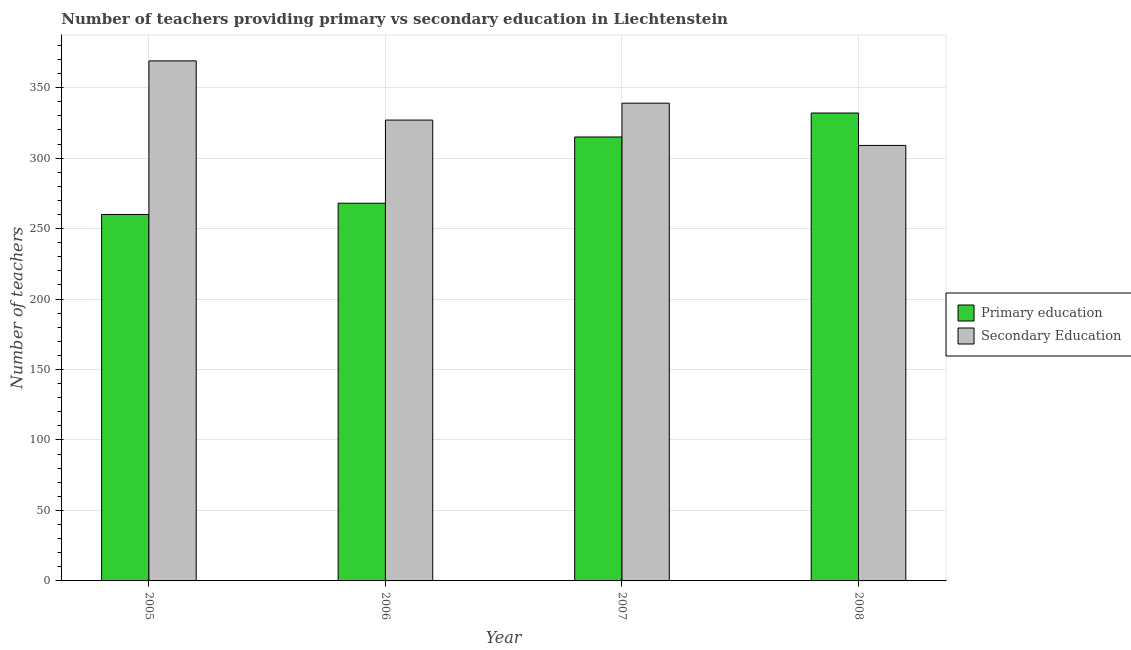Are the number of bars per tick equal to the number of legend labels?
Your answer should be very brief. Yes. How many bars are there on the 4th tick from the right?
Your answer should be compact. 2. What is the number of secondary teachers in 2006?
Give a very brief answer. 327. Across all years, what is the maximum number of secondary teachers?
Provide a short and direct response. 369. Across all years, what is the minimum number of primary teachers?
Your response must be concise. 260. In which year was the number of secondary teachers maximum?
Make the answer very short. 2005. In which year was the number of primary teachers minimum?
Offer a terse response. 2005. What is the total number of primary teachers in the graph?
Keep it short and to the point. 1175. What is the difference between the number of primary teachers in 2006 and that in 2008?
Offer a terse response. -64. What is the difference between the number of secondary teachers in 2005 and the number of primary teachers in 2008?
Your answer should be very brief. 60. What is the average number of primary teachers per year?
Provide a short and direct response. 293.75. In the year 2006, what is the difference between the number of primary teachers and number of secondary teachers?
Your response must be concise. 0. What is the ratio of the number of secondary teachers in 2007 to that in 2008?
Offer a terse response. 1.1. Is the number of primary teachers in 2007 less than that in 2008?
Your answer should be compact. Yes. Is the difference between the number of primary teachers in 2007 and 2008 greater than the difference between the number of secondary teachers in 2007 and 2008?
Your answer should be very brief. No. What is the difference between the highest and the lowest number of primary teachers?
Provide a short and direct response. 72. Is the sum of the number of primary teachers in 2005 and 2007 greater than the maximum number of secondary teachers across all years?
Your response must be concise. Yes. What does the 2nd bar from the left in 2006 represents?
Offer a terse response. Secondary Education. What does the 2nd bar from the right in 2006 represents?
Offer a terse response. Primary education. How many bars are there?
Your response must be concise. 8. How many years are there in the graph?
Keep it short and to the point. 4. Are the values on the major ticks of Y-axis written in scientific E-notation?
Ensure brevity in your answer.  No. How are the legend labels stacked?
Give a very brief answer. Vertical. What is the title of the graph?
Make the answer very short. Number of teachers providing primary vs secondary education in Liechtenstein. Does "Highest 20% of population" appear as one of the legend labels in the graph?
Give a very brief answer. No. What is the label or title of the Y-axis?
Your response must be concise. Number of teachers. What is the Number of teachers of Primary education in 2005?
Keep it short and to the point. 260. What is the Number of teachers of Secondary Education in 2005?
Keep it short and to the point. 369. What is the Number of teachers in Primary education in 2006?
Offer a very short reply. 268. What is the Number of teachers in Secondary Education in 2006?
Offer a terse response. 327. What is the Number of teachers in Primary education in 2007?
Your answer should be very brief. 315. What is the Number of teachers in Secondary Education in 2007?
Your answer should be very brief. 339. What is the Number of teachers of Primary education in 2008?
Provide a short and direct response. 332. What is the Number of teachers in Secondary Education in 2008?
Your answer should be compact. 309. Across all years, what is the maximum Number of teachers in Primary education?
Make the answer very short. 332. Across all years, what is the maximum Number of teachers in Secondary Education?
Keep it short and to the point. 369. Across all years, what is the minimum Number of teachers in Primary education?
Your answer should be very brief. 260. Across all years, what is the minimum Number of teachers of Secondary Education?
Your answer should be compact. 309. What is the total Number of teachers in Primary education in the graph?
Provide a short and direct response. 1175. What is the total Number of teachers of Secondary Education in the graph?
Your answer should be compact. 1344. What is the difference between the Number of teachers of Secondary Education in 2005 and that in 2006?
Ensure brevity in your answer.  42. What is the difference between the Number of teachers in Primary education in 2005 and that in 2007?
Ensure brevity in your answer.  -55. What is the difference between the Number of teachers in Primary education in 2005 and that in 2008?
Give a very brief answer. -72. What is the difference between the Number of teachers in Secondary Education in 2005 and that in 2008?
Offer a terse response. 60. What is the difference between the Number of teachers of Primary education in 2006 and that in 2007?
Provide a short and direct response. -47. What is the difference between the Number of teachers of Secondary Education in 2006 and that in 2007?
Your response must be concise. -12. What is the difference between the Number of teachers of Primary education in 2006 and that in 2008?
Keep it short and to the point. -64. What is the difference between the Number of teachers of Primary education in 2007 and that in 2008?
Your answer should be very brief. -17. What is the difference between the Number of teachers in Primary education in 2005 and the Number of teachers in Secondary Education in 2006?
Make the answer very short. -67. What is the difference between the Number of teachers of Primary education in 2005 and the Number of teachers of Secondary Education in 2007?
Provide a succinct answer. -79. What is the difference between the Number of teachers of Primary education in 2005 and the Number of teachers of Secondary Education in 2008?
Your answer should be very brief. -49. What is the difference between the Number of teachers of Primary education in 2006 and the Number of teachers of Secondary Education in 2007?
Offer a very short reply. -71. What is the difference between the Number of teachers of Primary education in 2006 and the Number of teachers of Secondary Education in 2008?
Make the answer very short. -41. What is the difference between the Number of teachers in Primary education in 2007 and the Number of teachers in Secondary Education in 2008?
Your answer should be compact. 6. What is the average Number of teachers of Primary education per year?
Your response must be concise. 293.75. What is the average Number of teachers of Secondary Education per year?
Provide a succinct answer. 336. In the year 2005, what is the difference between the Number of teachers of Primary education and Number of teachers of Secondary Education?
Offer a very short reply. -109. In the year 2006, what is the difference between the Number of teachers in Primary education and Number of teachers in Secondary Education?
Make the answer very short. -59. What is the ratio of the Number of teachers of Primary education in 2005 to that in 2006?
Your answer should be very brief. 0.97. What is the ratio of the Number of teachers of Secondary Education in 2005 to that in 2006?
Ensure brevity in your answer.  1.13. What is the ratio of the Number of teachers of Primary education in 2005 to that in 2007?
Your response must be concise. 0.83. What is the ratio of the Number of teachers in Secondary Education in 2005 to that in 2007?
Make the answer very short. 1.09. What is the ratio of the Number of teachers in Primary education in 2005 to that in 2008?
Make the answer very short. 0.78. What is the ratio of the Number of teachers of Secondary Education in 2005 to that in 2008?
Make the answer very short. 1.19. What is the ratio of the Number of teachers of Primary education in 2006 to that in 2007?
Provide a succinct answer. 0.85. What is the ratio of the Number of teachers in Secondary Education in 2006 to that in 2007?
Give a very brief answer. 0.96. What is the ratio of the Number of teachers of Primary education in 2006 to that in 2008?
Give a very brief answer. 0.81. What is the ratio of the Number of teachers of Secondary Education in 2006 to that in 2008?
Make the answer very short. 1.06. What is the ratio of the Number of teachers in Primary education in 2007 to that in 2008?
Your response must be concise. 0.95. What is the ratio of the Number of teachers of Secondary Education in 2007 to that in 2008?
Make the answer very short. 1.1. What is the difference between the highest and the second highest Number of teachers in Primary education?
Give a very brief answer. 17. What is the difference between the highest and the second highest Number of teachers in Secondary Education?
Offer a very short reply. 30. What is the difference between the highest and the lowest Number of teachers in Primary education?
Your answer should be very brief. 72. 